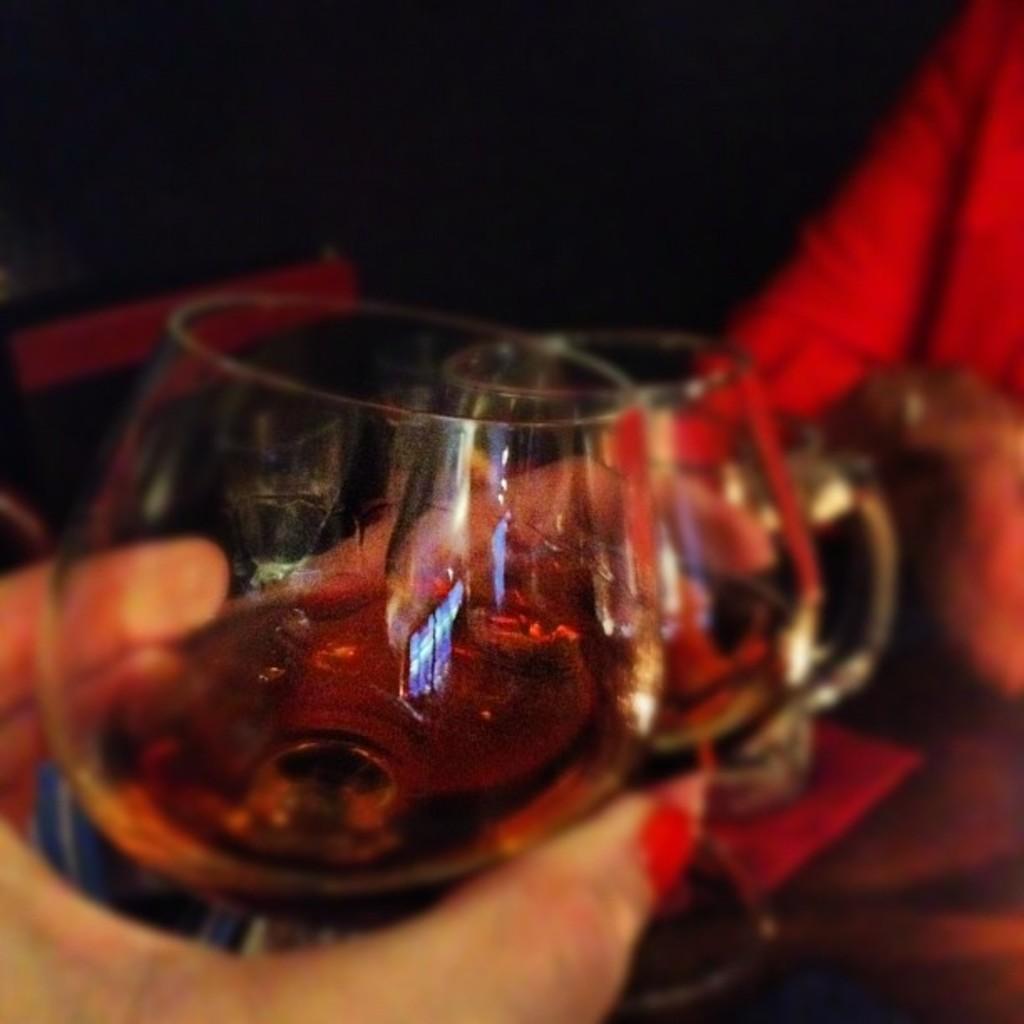Describe this image in one or two sentences. In this picture I can see two persons holding glass of wine and the background is blurry. 